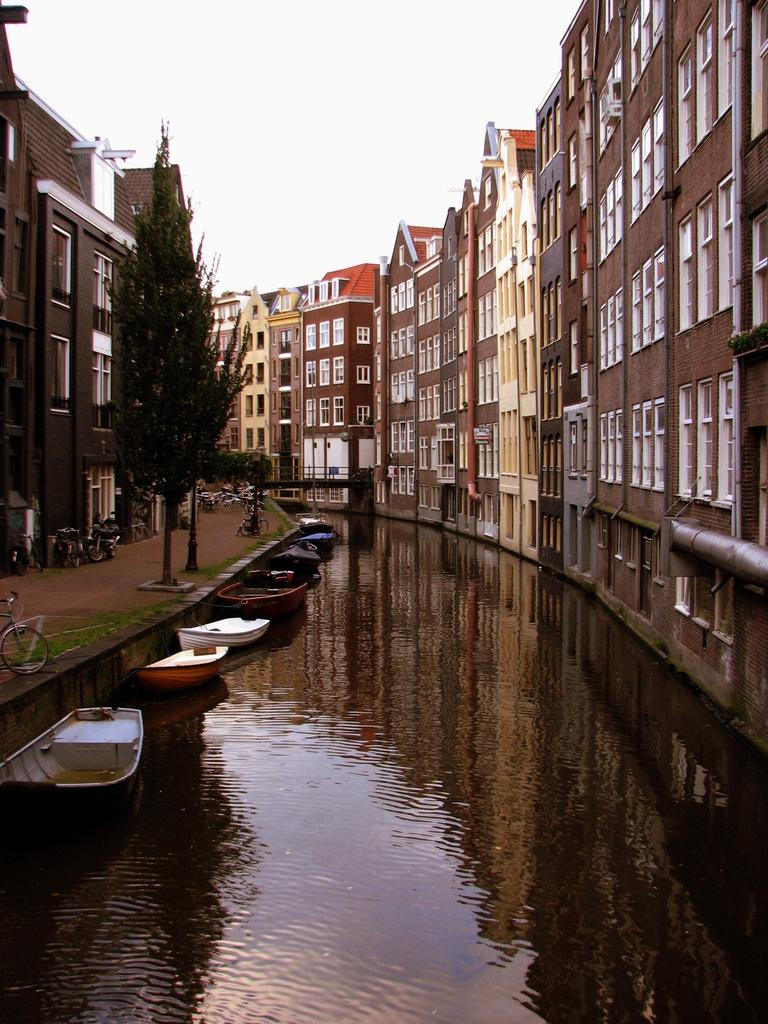What type of structures can be seen in the image? There are buildings in the image. What architectural features are present in the image? There are walls and windows visible in the image. What type of vegetation is present in the image? There are trees in the image. What mode of transportation can be seen in the image? There are vehicles in the image. What pathway is visible in the image? There is a walkway in the image. What is floating above the water in the image? There are boats above the water in the image. What part of the natural environment is visible in the image? The sky is visible at the top of the image. What type of rice is being served in the school cafeteria in the image? There is no school or cafeteria present in the image, and therefore no rice being served. What is the porter carrying in the image? There is no porter present in the image, so it is not possible to determine what they might be carrying. 